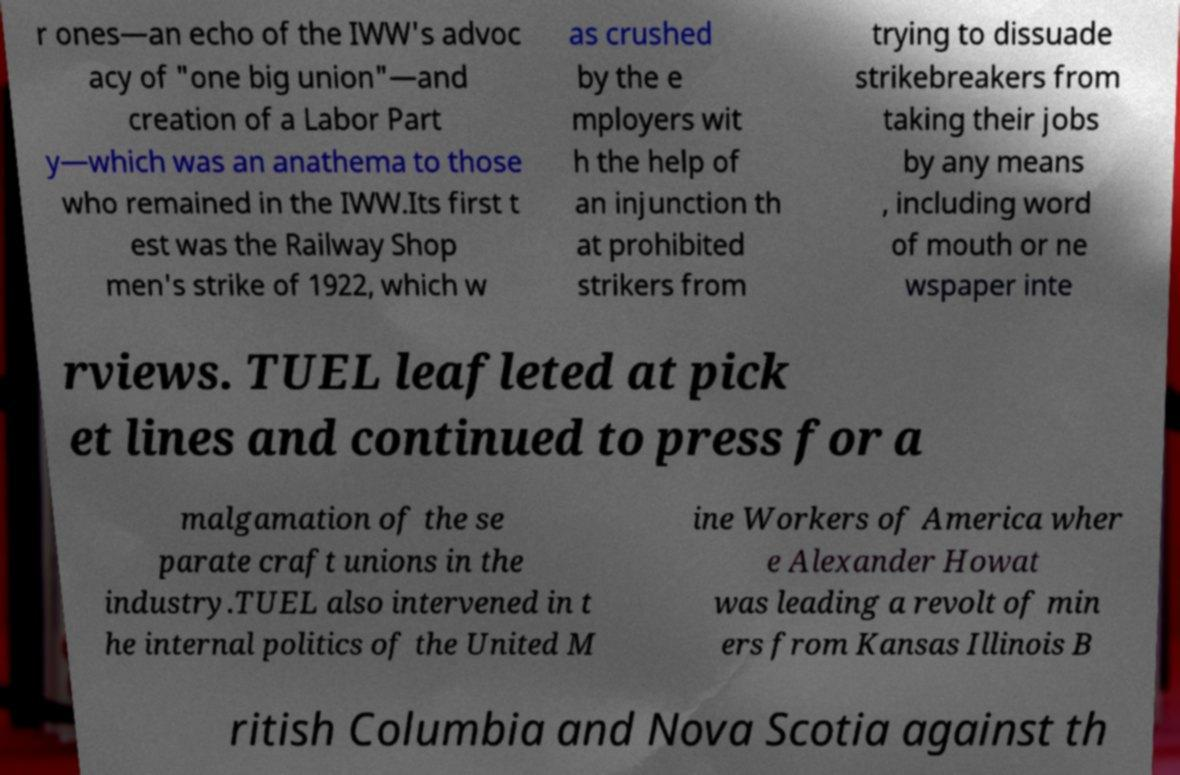Can you read and provide the text displayed in the image?This photo seems to have some interesting text. Can you extract and type it out for me? r ones—an echo of the IWW's advoc acy of "one big union"—and creation of a Labor Part y—which was an anathema to those who remained in the IWW.Its first t est was the Railway Shop men's strike of 1922, which w as crushed by the e mployers wit h the help of an injunction th at prohibited strikers from trying to dissuade strikebreakers from taking their jobs by any means , including word of mouth or ne wspaper inte rviews. TUEL leafleted at pick et lines and continued to press for a malgamation of the se parate craft unions in the industry.TUEL also intervened in t he internal politics of the United M ine Workers of America wher e Alexander Howat was leading a revolt of min ers from Kansas Illinois B ritish Columbia and Nova Scotia against th 